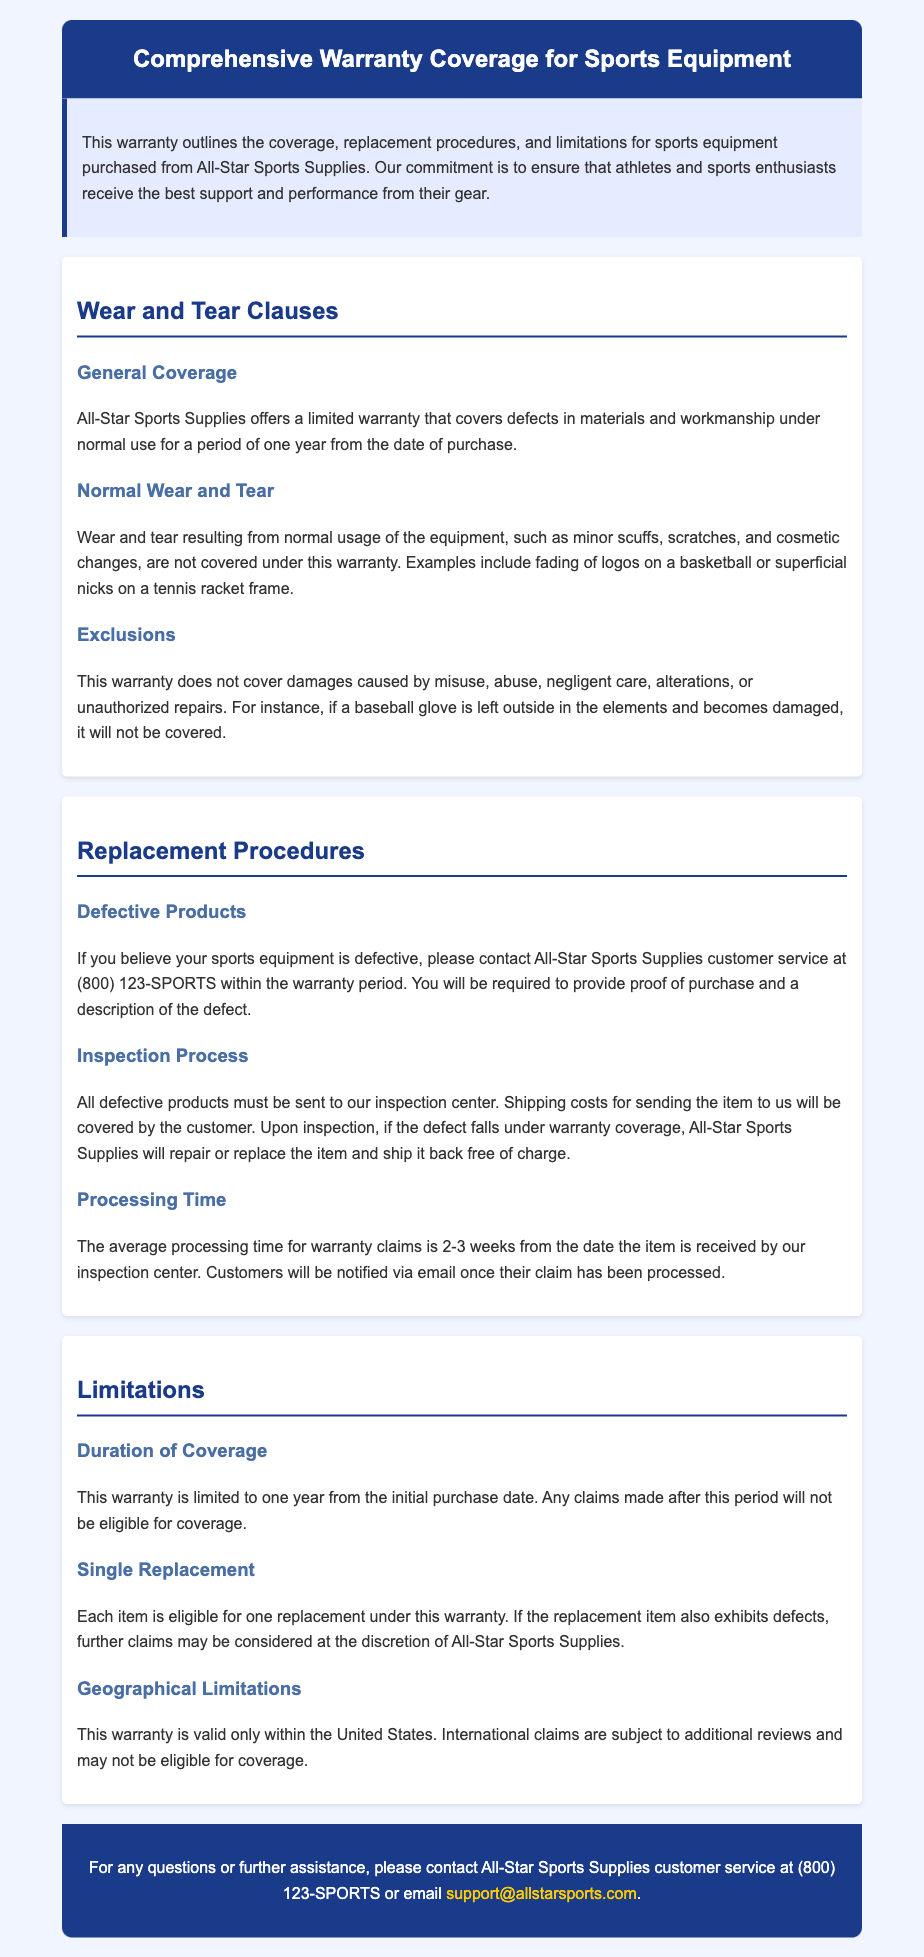What is the duration of the warranty coverage? The document states that the warranty is limited to one year from the initial purchase date.
Answer: one year What must customers provide when claiming a defect? The warranty outlines that customers need to provide proof of purchase and a description of the defect.
Answer: proof of purchase and a description of the defect What types of damage does the warranty not cover? The warranty excludes damages caused by misuse, abuse, negligent care, alterations, or unauthorized repairs.
Answer: misuse, abuse, negligent care, alterations, or unauthorized repairs How long is the average processing time for warranty claims? The average processing time stated in the document is 2-3 weeks from the date the item is received.
Answer: 2-3 weeks How many replacements is each item eligible for under the warranty? The warranty specifies that each item is eligible for one replacement under this warranty.
Answer: one replacement What should customers do if they believe their equipment is defective? Customers are instructed to contact All-Star Sports Supplies customer service within the warranty period.
Answer: contact All-Star Sports Supplies customer service Where should defective products be sent for inspection? The document specifies that all defective products must be sent to the inspection center of All-Star Sports Supplies.
Answer: inspection center Is the warranty applicable internationally? The document indicates that this warranty is valid only within the United States.
Answer: only within the United States What type of wear is covered under the warranty? The warranty covers defects in materials and workmanship under normal use for a period of one year.
Answer: defects in materials and workmanship under normal use 